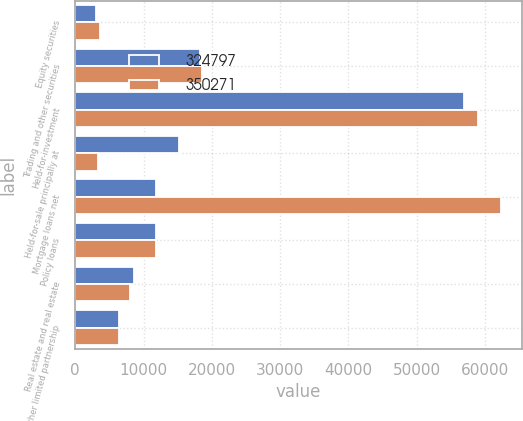<chart> <loc_0><loc_0><loc_500><loc_500><stacked_bar_chart><ecel><fcel>Equity securities<fcel>Trading and other securities<fcel>Held-for-investment<fcel>Held-for-sale principally at<fcel>Mortgage loans net<fcel>Policy loans<fcel>Real estate and real estate<fcel>Other limited partnership<nl><fcel>324797<fcel>3023<fcel>18268<fcel>56915<fcel>15178<fcel>11761<fcel>11892<fcel>8563<fcel>6378<nl><fcel>350271<fcel>3602<fcel>18589<fcel>58976<fcel>3321<fcel>62297<fcel>11761<fcel>8030<fcel>6416<nl></chart> 